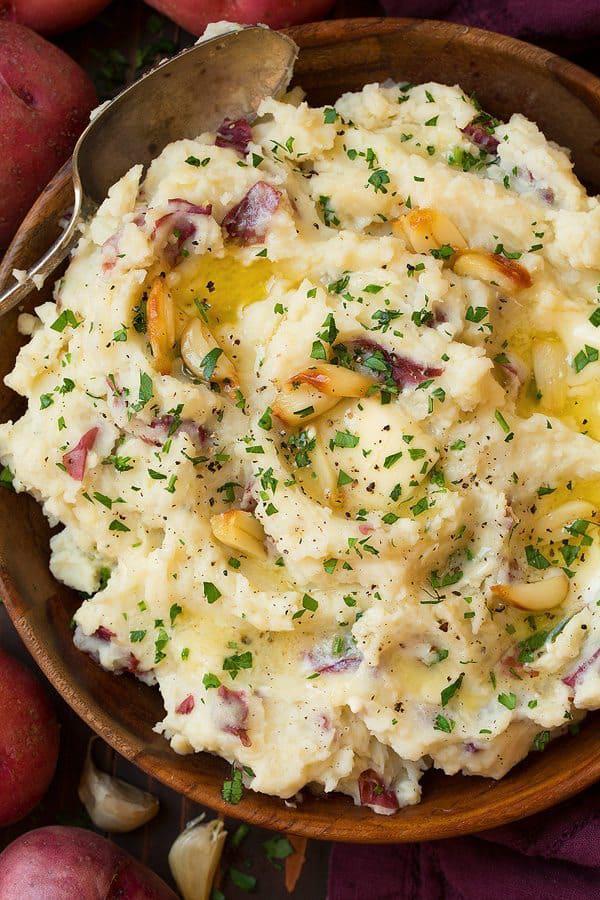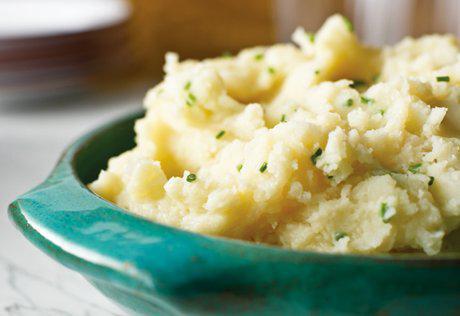The first image is the image on the left, the second image is the image on the right. Examine the images to the left and right. Is the description "Large flakes of green garnish adorn the potatoes in the image on left." accurate? Answer yes or no. Yes. The first image is the image on the left, the second image is the image on the right. Assess this claim about the two images: "One image shows food in a white bowl, and the other does not.". Correct or not? Answer yes or no. No. 